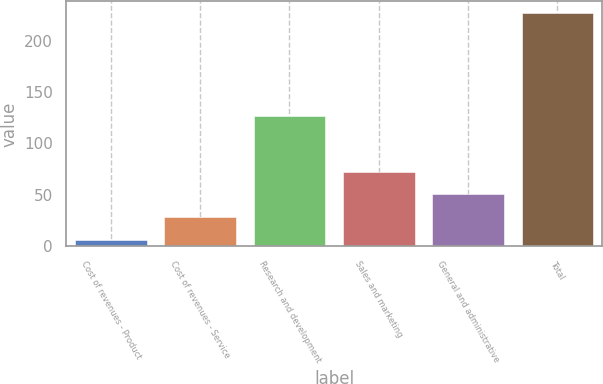<chart> <loc_0><loc_0><loc_500><loc_500><bar_chart><fcel>Cost of revenues - Product<fcel>Cost of revenues - Service<fcel>Research and development<fcel>Sales and marketing<fcel>General and administrative<fcel>Total<nl><fcel>6.4<fcel>28.44<fcel>126.5<fcel>72.52<fcel>50.48<fcel>226.8<nl></chart> 